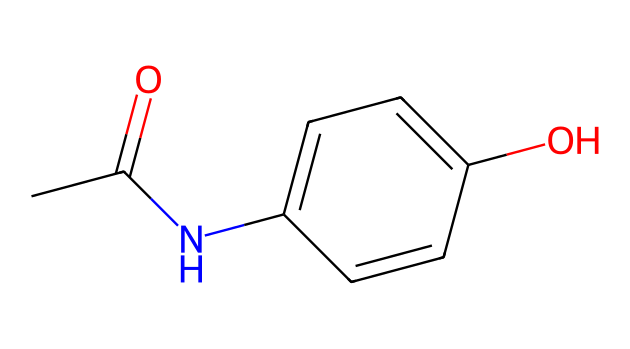What is the name of this chemical? This chemical structure corresponds to the SMILES representation provided, which is commonly known as acetaminophen or paracetamol, widely used as a pain reliever and fever reducer.
Answer: acetaminophen How many carbon atoms are in acetaminophen? To determine the number of carbon atoms, we can identify each 'C' in the SMILES representation. In the structure, there are six carbon atoms indicated in the aromatic ring and two in the acetyl group, totaling eight carbon atoms.
Answer: 8 What functional groups are present in acetaminophen? Looking at the chemical structure, the functional groups present include an amide (indicated by the -N-CO group) and a hydroxyl group (-OH). These groups are characteristic of its properties as a medication.
Answer: amide and hydroxyl What is the total number of nitrogen atoms in acetaminophen? Analyzing the SMILES representation, we find that there is only one nitrogen atom present in the structure, located in the amide group.
Answer: 1 What type of bond connects the nitrogen and carbon in the amide group? In the structure, the bond between nitrogen and carbon in the amide group is a covalent bond, specifically a single bond, as indicated by the absence of any multiple bonds in that part of the structure.
Answer: single bond How many hydroxyl (OH) groups are present in the acetaminophen structure? By examining the chemical structure, we locate one hydroxyl group (-OH) attached to the aromatic ring, which is part of the overall molecular arrangement of the compound.
Answer: 1 What is the significance of the acetyl group in acetaminophen? The acetyl group (-COCH3) is crucial as it contributes to the analgesic (pain-relieving) and antipyretic (fever-reducing) properties of acetaminophen, impacting its mechanism of action in the body.
Answer: analgesic and antipyretic properties 